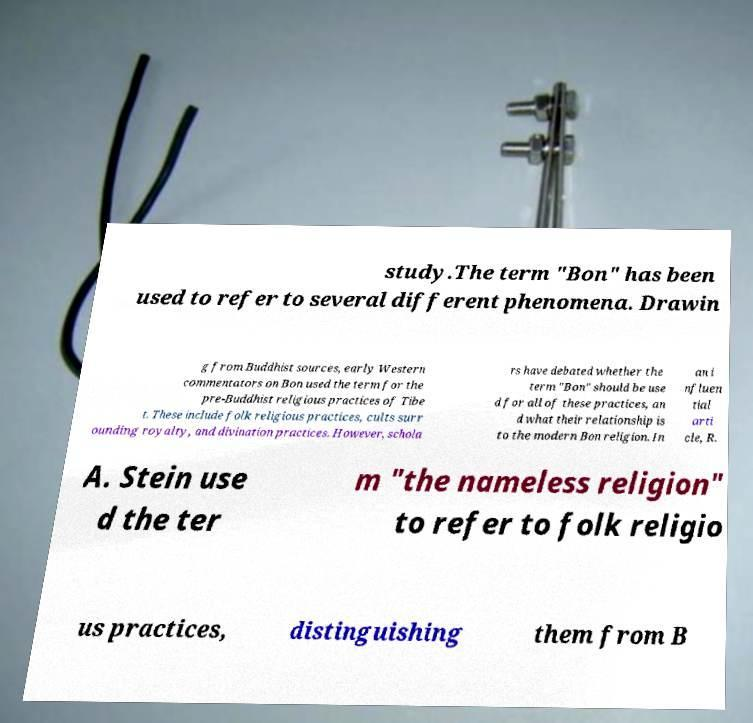I need the written content from this picture converted into text. Can you do that? study.The term "Bon" has been used to refer to several different phenomena. Drawin g from Buddhist sources, early Western commentators on Bon used the term for the pre-Buddhist religious practices of Tibe t. These include folk religious practices, cults surr ounding royalty, and divination practices. However, schola rs have debated whether the term "Bon" should be use d for all of these practices, an d what their relationship is to the modern Bon religion. In an i nfluen tial arti cle, R. A. Stein use d the ter m "the nameless religion" to refer to folk religio us practices, distinguishing them from B 